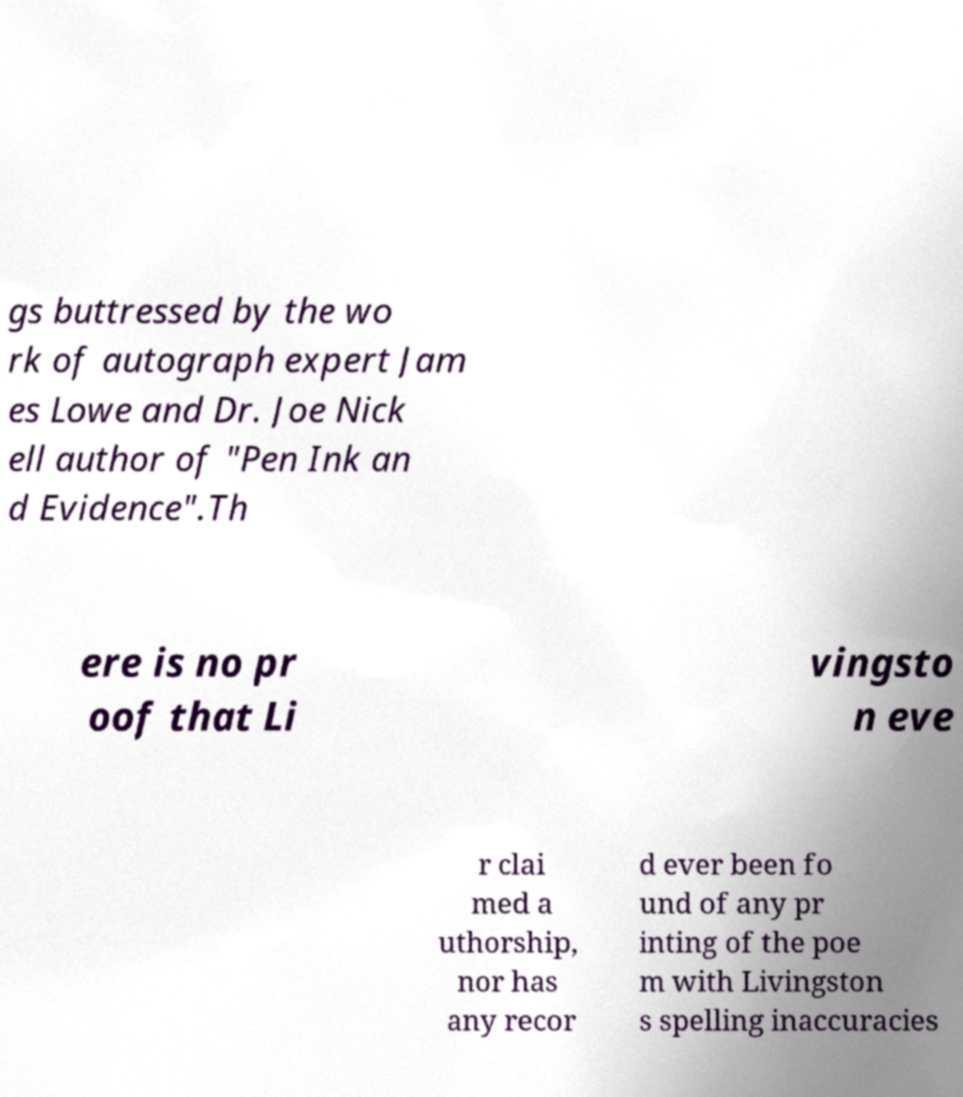There's text embedded in this image that I need extracted. Can you transcribe it verbatim? gs buttressed by the wo rk of autograph expert Jam es Lowe and Dr. Joe Nick ell author of "Pen Ink an d Evidence".Th ere is no pr oof that Li vingsto n eve r clai med a uthorship, nor has any recor d ever been fo und of any pr inting of the poe m with Livingston s spelling inaccuracies 